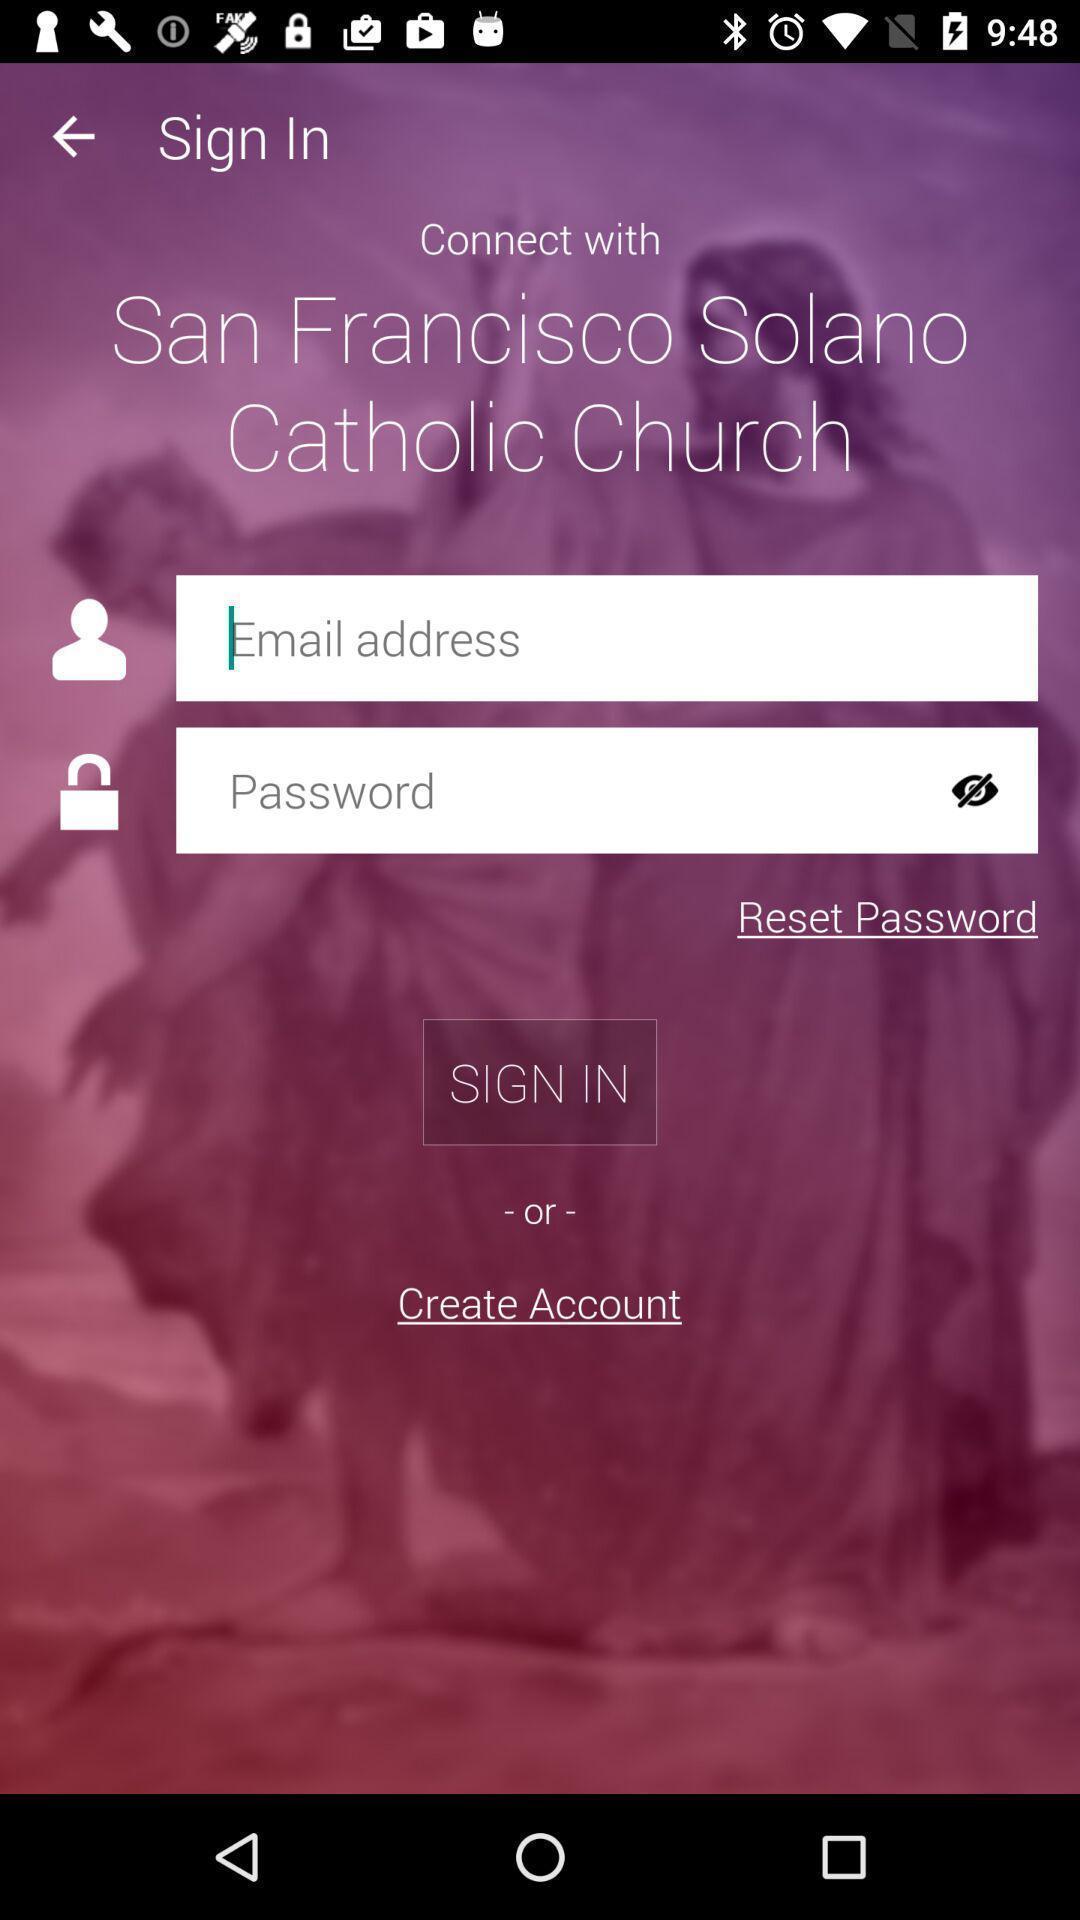Describe the visual elements of this screenshot. Sign-in page of a prayer app. 